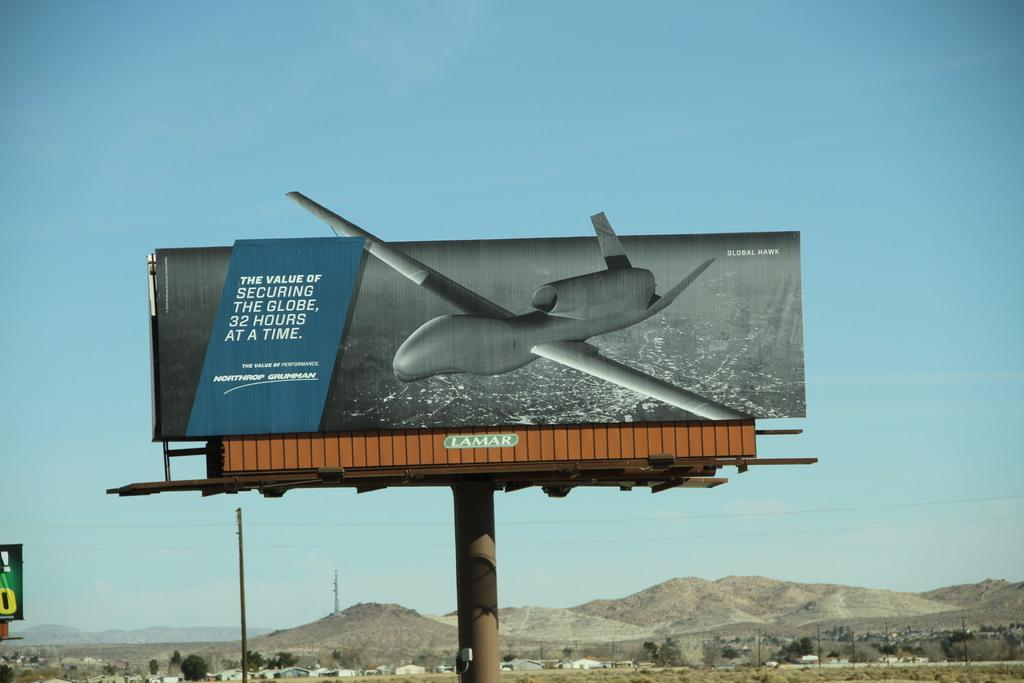What is the main subject in the center of the image? There is a poster in the center of the image. What can be seen at the bottom side of the image? There are houses and trees at the bottom side of the image. How many boys are holding flowers under the star in the image? There are no boys, flowers, or stars present in the image. 